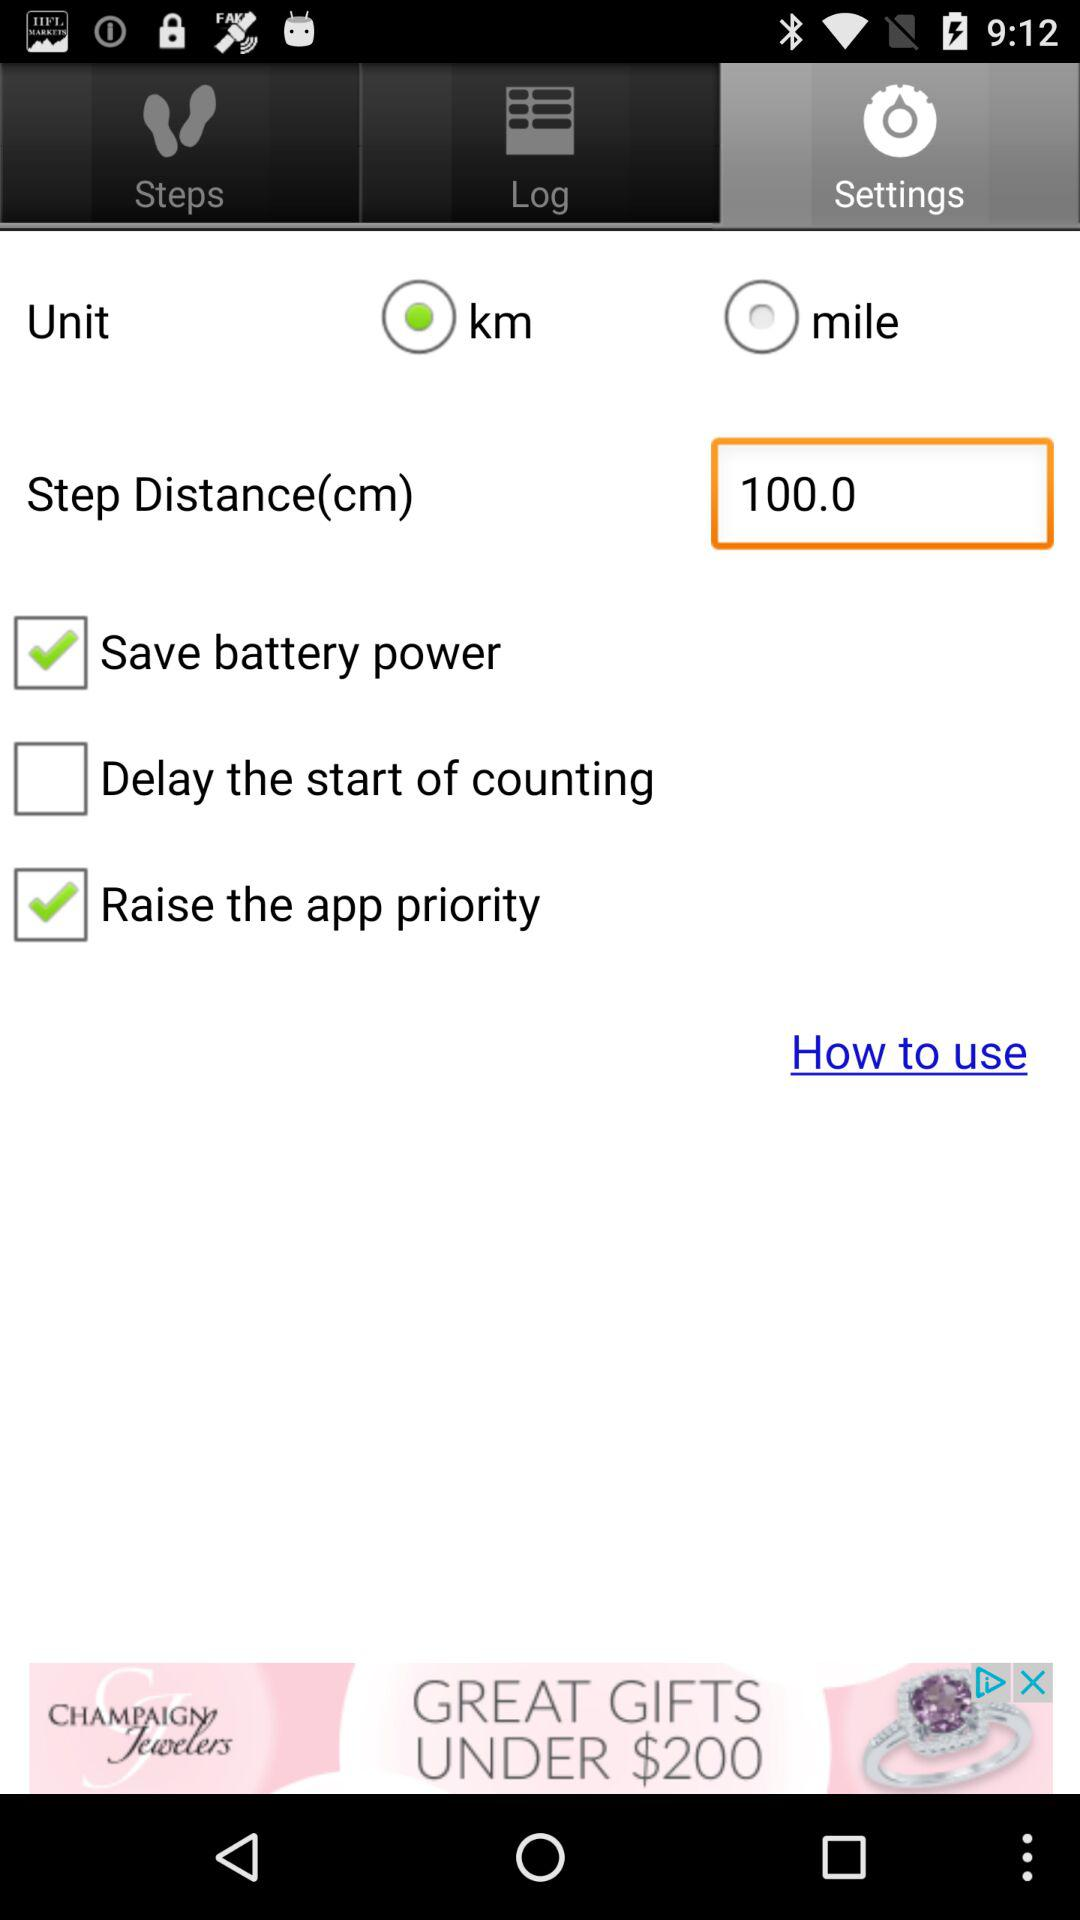What is the step distance? The step distance is 100.0 cm. 